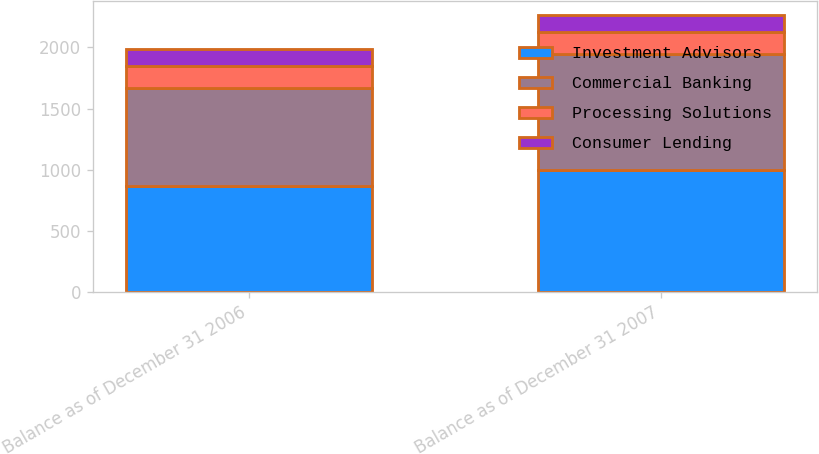Convert chart to OTSL. <chart><loc_0><loc_0><loc_500><loc_500><stacked_bar_chart><ecel><fcel>Balance as of December 31 2006<fcel>Balance as of December 31 2007<nl><fcel>Investment Advisors<fcel>871<fcel>995<nl><fcel>Commercial Banking<fcel>797<fcel>950<nl><fcel>Processing Solutions<fcel>182<fcel>182<nl><fcel>Consumer Lending<fcel>138<fcel>138<nl></chart> 